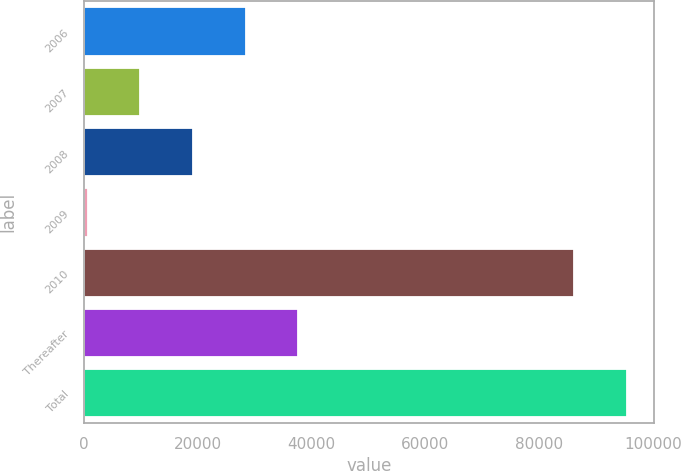<chart> <loc_0><loc_0><loc_500><loc_500><bar_chart><fcel>2006<fcel>2007<fcel>2008<fcel>2009<fcel>2010<fcel>Thereafter<fcel>Total<nl><fcel>28390.7<fcel>9888.9<fcel>19139.8<fcel>638<fcel>86184<fcel>37641.6<fcel>95434.9<nl></chart> 